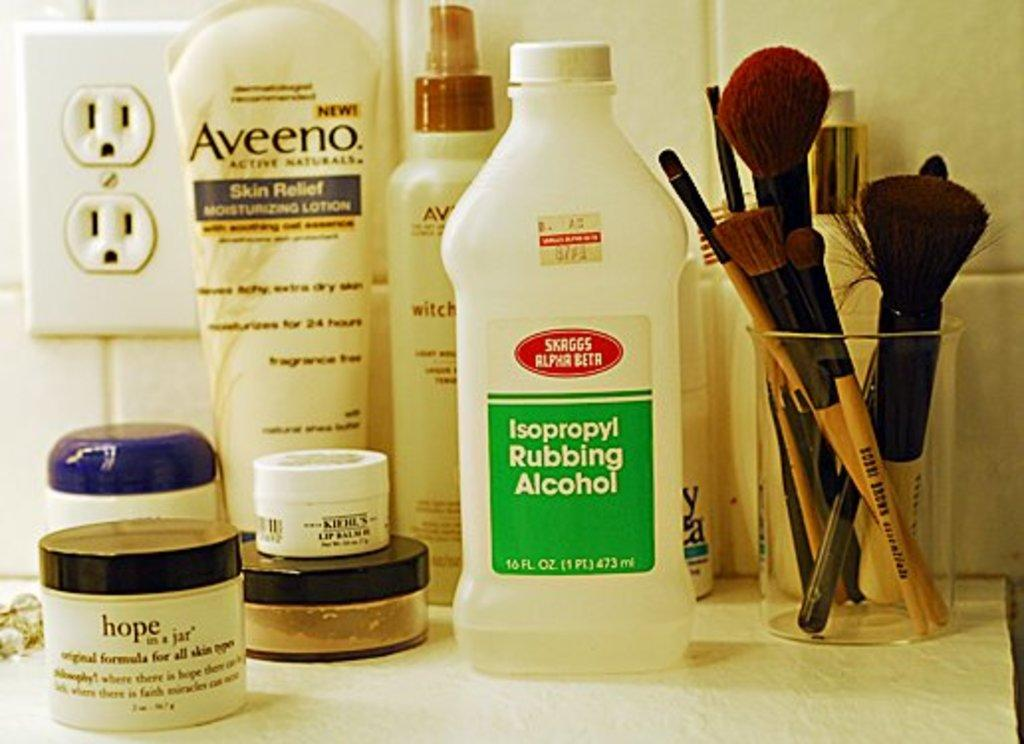<image>
Provide a brief description of the given image. A bunch of products sitting in a bathroom including Isopropyl Rubbing Alcohol. 